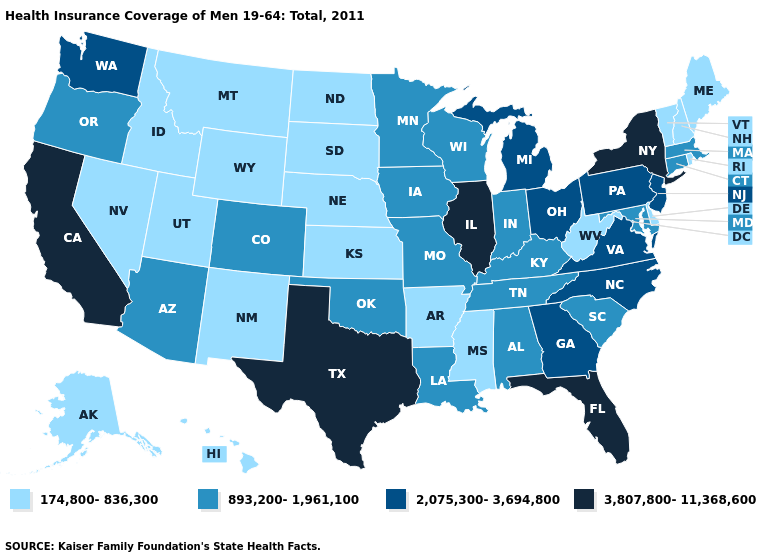Name the states that have a value in the range 3,807,800-11,368,600?
Concise answer only. California, Florida, Illinois, New York, Texas. Does Hawaii have the same value as Idaho?
Answer briefly. Yes. What is the highest value in the West ?
Concise answer only. 3,807,800-11,368,600. What is the value of Idaho?
Keep it brief. 174,800-836,300. Does the first symbol in the legend represent the smallest category?
Quick response, please. Yes. Does California have a lower value than West Virginia?
Keep it brief. No. What is the value of Georgia?
Keep it brief. 2,075,300-3,694,800. Does Utah have the same value as Maine?
Give a very brief answer. Yes. Does Massachusetts have the highest value in the Northeast?
Write a very short answer. No. Name the states that have a value in the range 3,807,800-11,368,600?
Be succinct. California, Florida, Illinois, New York, Texas. Which states have the lowest value in the USA?
Be succinct. Alaska, Arkansas, Delaware, Hawaii, Idaho, Kansas, Maine, Mississippi, Montana, Nebraska, Nevada, New Hampshire, New Mexico, North Dakota, Rhode Island, South Dakota, Utah, Vermont, West Virginia, Wyoming. Name the states that have a value in the range 2,075,300-3,694,800?
Write a very short answer. Georgia, Michigan, New Jersey, North Carolina, Ohio, Pennsylvania, Virginia, Washington. Name the states that have a value in the range 174,800-836,300?
Write a very short answer. Alaska, Arkansas, Delaware, Hawaii, Idaho, Kansas, Maine, Mississippi, Montana, Nebraska, Nevada, New Hampshire, New Mexico, North Dakota, Rhode Island, South Dakota, Utah, Vermont, West Virginia, Wyoming. Does New York have the lowest value in the Northeast?
Concise answer only. No. Name the states that have a value in the range 2,075,300-3,694,800?
Concise answer only. Georgia, Michigan, New Jersey, North Carolina, Ohio, Pennsylvania, Virginia, Washington. 